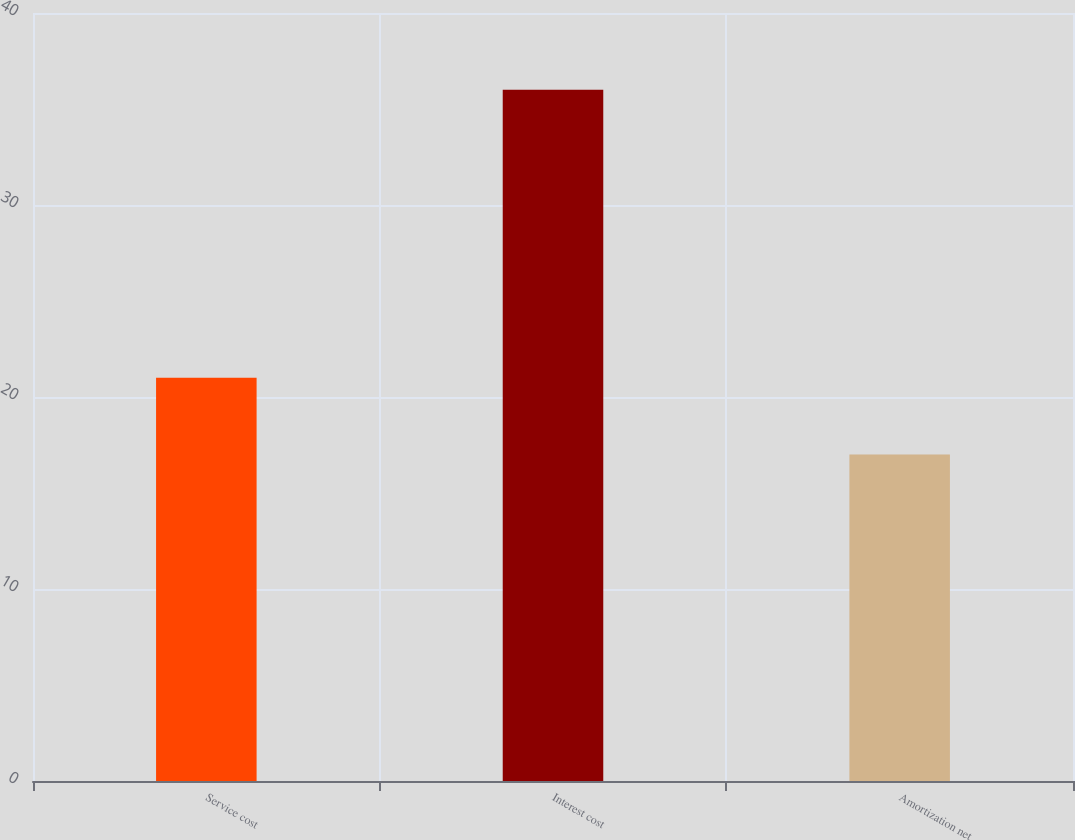Convert chart. <chart><loc_0><loc_0><loc_500><loc_500><bar_chart><fcel>Service cost<fcel>Interest cost<fcel>Amortization net<nl><fcel>21<fcel>36<fcel>17<nl></chart> 